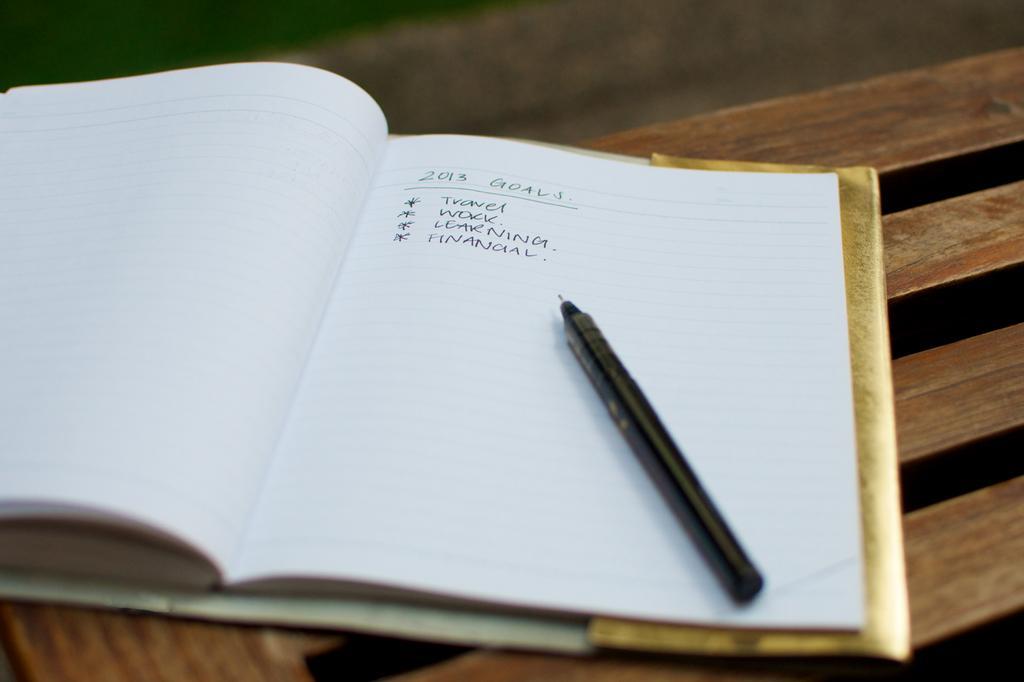Can you describe this image briefly? In this image there is a wooden surface, on top there is a book and a pen, on that there is some text written. 